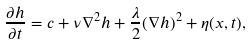<formula> <loc_0><loc_0><loc_500><loc_500>\frac { \partial h } { \partial t } = c + \nu \nabla ^ { 2 } h + \frac { \lambda } { 2 } ( \nabla h ) ^ { 2 } + \eta ( x , t ) ,</formula> 